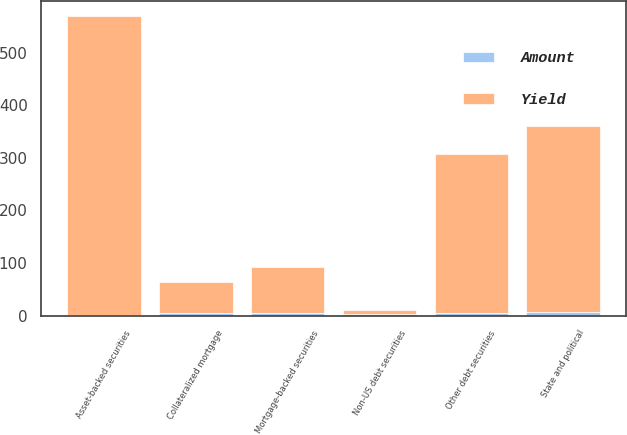<chart> <loc_0><loc_0><loc_500><loc_500><stacked_bar_chart><ecel><fcel>Mortgage-backed securities<fcel>Asset-backed securities<fcel>Collateralized mortgage<fcel>State and political<fcel>Non-US debt securities<fcel>Other debt securities<nl><fcel>Yield<fcel>89<fcel>569<fcel>58<fcel>354<fcel>6.65<fcel>303<nl><fcel>Amount<fcel>4.16<fcel>1.36<fcel>5.26<fcel>6.65<fcel>3.34<fcel>5.22<nl></chart> 